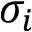<formula> <loc_0><loc_0><loc_500><loc_500>\sigma _ { i }</formula> 